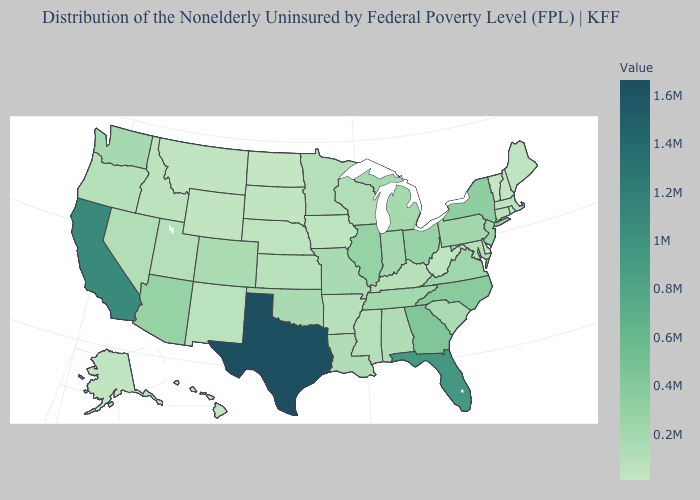Which states have the lowest value in the West?
Be succinct. Hawaii. Does the map have missing data?
Keep it brief. No. Among the states that border Nevada , which have the highest value?
Short answer required. California. Among the states that border Idaho , which have the lowest value?
Be succinct. Wyoming. Which states have the lowest value in the South?
Keep it brief. Delaware. Which states have the lowest value in the USA?
Quick response, please. Vermont. Does Alaska have a lower value than Virginia?
Keep it brief. Yes. 